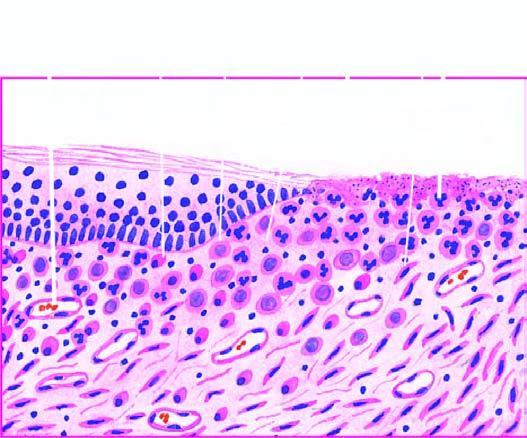does bilayer lipid membrane have inflammatory cell infiltrate, newly formed blood vessels and young fibrous tissue in loose matrix?
Answer the question using a single word or phrase. No 